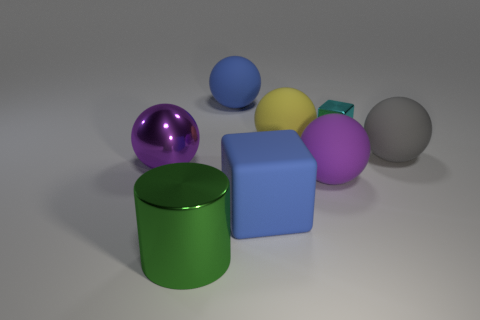Subtract all big matte spheres. How many spheres are left? 1 Subtract all yellow spheres. How many spheres are left? 4 Add 1 big matte balls. How many objects exist? 9 Subtract all purple cylinders. How many brown blocks are left? 0 Subtract 3 spheres. How many spheres are left? 2 Subtract all blue spheres. Subtract all blue cubes. How many spheres are left? 4 Subtract all big yellow objects. Subtract all green cylinders. How many objects are left? 6 Add 3 yellow balls. How many yellow balls are left? 4 Add 8 large gray matte balls. How many large gray matte balls exist? 9 Subtract 0 yellow cylinders. How many objects are left? 8 